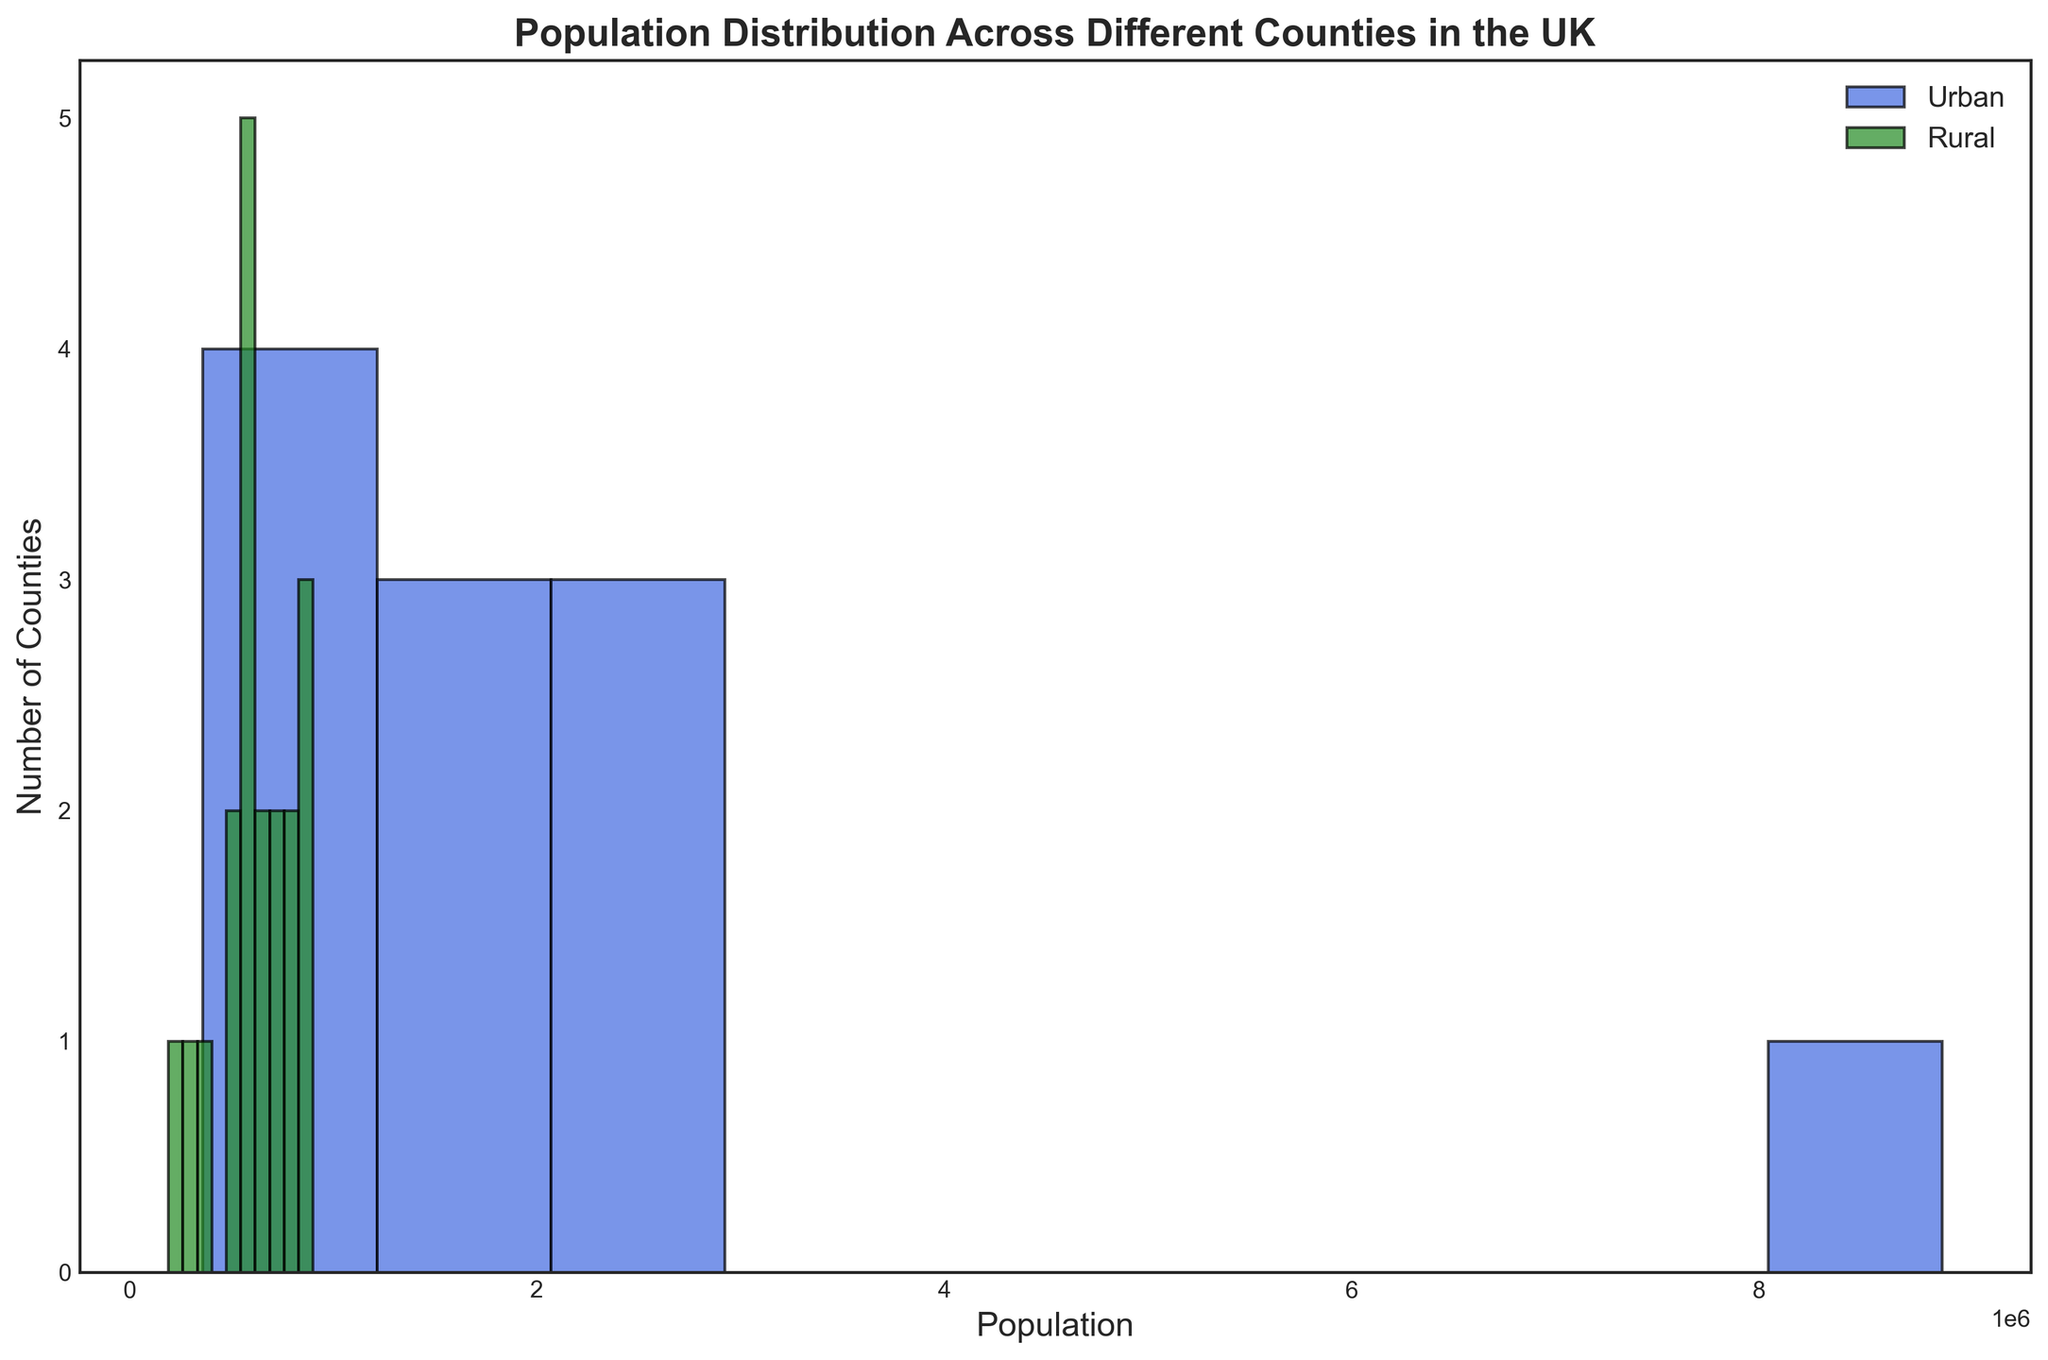what general trend is observed between urban and rural counties in terms of population? By looking at the histogram, urban counties tend to have higher population counts compared to rural counties. Urban areas appear concentrated in higher population bins, while rural areas are more spread out across lower population bins.
Answer: Urban counties generally have higher populations than rural counties Which area type has counties with populations in the highest bin range? Observing the highest population bin on the x-axis and seeing which color appears, we notice that only urban areas (blue bars) are present in the highest population range.
Answer: Urban How many counties have a population of roughly 2.5 million? Look at the histogram bins to find the one closest to 2.5 million in the x-axis, then check the height of the bars for both urban and rural areas. The bar height denotes the number of counties in that population range.
Answer: 2 counties Which area type shows more diversity in population distribution? Compare the spread of urban and rural bars across different population ranges. Rural areas (green bars) are spread more broadly, indicating diverse population distributions.
Answer: Rural What is the population range with the highest number of rural counties? Identify the bin range with the tallest green bars on the histogram.
Answer: Around 700,000 to 800,000 Does any rural county have a population greater than 1 million? Analyze the histogram for any green bars (rural areas) beyond the 1 million population mark on the x-axis.
Answer: No Which area type has more counties with populations below 1 million? Compare the number of bars below the 1 million population mark for both blue (urban) and green (rural) colors.
Answer: Rural How does the number of urban counties in the 1-2 million range compare to the number of urban counties in the below-1 million range? Check the urban (blue bars) for two ranges: 1-2 million and below 1 million, and compare their heights.
Answer: More counties are in the below-1 million range What is the median population of rural counties? Since the population data is spread across bins, approximate by locating the central bin where half of the green bars lie on either side. This would seem to be around the 700,000 mark.
Answer: Approximately 700,000 Do urban or rural counties contribute more to the highest population density bin on the histogram? Examine the highest population density bins to see which area type (urban or rural) the bars belong to; the blue bars representing urban counties dominate these bins.
Answer: Urban 